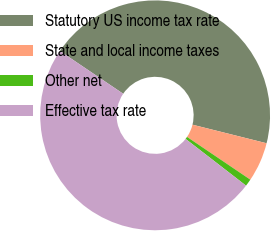Convert chart to OTSL. <chart><loc_0><loc_0><loc_500><loc_500><pie_chart><fcel>Statutory US income tax rate<fcel>State and local income taxes<fcel>Other net<fcel>Effective tax rate<nl><fcel>44.45%<fcel>5.55%<fcel>1.02%<fcel>48.98%<nl></chart> 